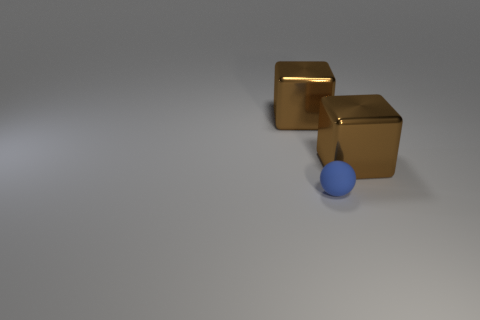Are there any large brown metallic cubes that are in front of the big brown metal object that is on the left side of the blue thing?
Offer a terse response. Yes. Is there a large brown thing of the same shape as the blue rubber object?
Your answer should be very brief. No. What material is the large brown thing that is behind the large metallic block on the right side of the matte sphere?
Your answer should be very brief. Metal. What is the size of the sphere?
Keep it short and to the point. Small. Do the block left of the blue object and the tiny blue ball have the same size?
Your answer should be very brief. No. What is the shape of the tiny blue matte object to the right of the cube behind the brown metal block that is to the right of the small matte ball?
Give a very brief answer. Sphere. What number of things are large brown objects or brown blocks right of the blue matte sphere?
Give a very brief answer. 2. There is a thing on the right side of the tiny blue rubber thing; what is its size?
Offer a terse response. Large. Is the tiny blue object made of the same material as the block to the left of the tiny blue matte ball?
Provide a short and direct response. No. There is a big brown object that is in front of the brown thing left of the matte object; what number of large metallic things are behind it?
Provide a succinct answer. 1. 